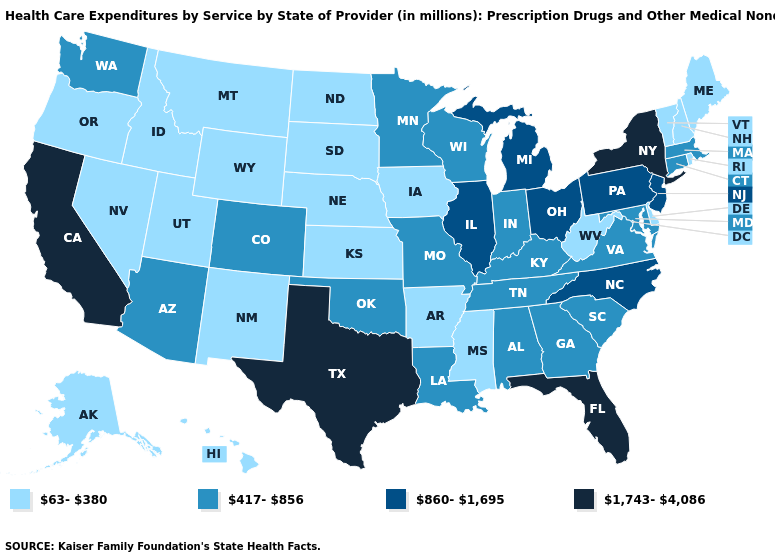Does Utah have the highest value in the USA?
Quick response, please. No. What is the value of Maryland?
Quick response, please. 417-856. Among the states that border Oregon , which have the lowest value?
Short answer required. Idaho, Nevada. Does Maine have the lowest value in the USA?
Give a very brief answer. Yes. What is the value of Mississippi?
Give a very brief answer. 63-380. What is the lowest value in the MidWest?
Concise answer only. 63-380. Name the states that have a value in the range 63-380?
Concise answer only. Alaska, Arkansas, Delaware, Hawaii, Idaho, Iowa, Kansas, Maine, Mississippi, Montana, Nebraska, Nevada, New Hampshire, New Mexico, North Dakota, Oregon, Rhode Island, South Dakota, Utah, Vermont, West Virginia, Wyoming. What is the value of Oklahoma?
Concise answer only. 417-856. Does Colorado have a lower value than Alaska?
Write a very short answer. No. What is the lowest value in the USA?
Keep it brief. 63-380. What is the value of Massachusetts?
Write a very short answer. 417-856. Name the states that have a value in the range 1,743-4,086?
Keep it brief. California, Florida, New York, Texas. What is the value of South Dakota?
Give a very brief answer. 63-380. Does Wisconsin have the lowest value in the MidWest?
Keep it brief. No. Among the states that border Delaware , which have the highest value?
Give a very brief answer. New Jersey, Pennsylvania. 